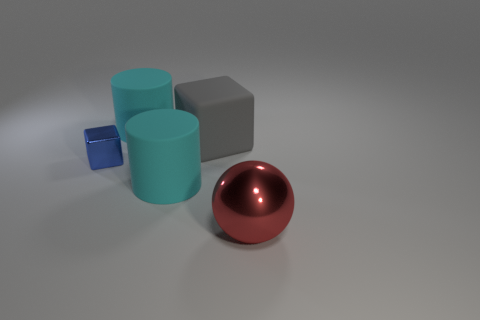How many other objects are the same color as the shiny ball?
Make the answer very short. 0. There is a shiny thing on the left side of the red shiny thing; does it have the same shape as the rubber object in front of the tiny shiny block?
Your answer should be compact. No. Is there a matte object that has the same size as the blue shiny cube?
Keep it short and to the point. No. There is a cyan cylinder behind the metal block; what is it made of?
Provide a short and direct response. Rubber. Do the cube that is on the left side of the gray matte block and the sphere have the same material?
Your answer should be compact. Yes. Is there a tiny gray matte cylinder?
Provide a succinct answer. No. There is another object that is made of the same material as the red thing; what is its color?
Keep it short and to the point. Blue. The thing that is to the left of the big rubber cylinder that is behind the shiny object that is behind the red sphere is what color?
Keep it short and to the point. Blue. There is a red sphere; is its size the same as the cube that is in front of the big cube?
Offer a terse response. No. How many things are metal objects behind the red ball or big gray rubber cubes that are right of the small thing?
Give a very brief answer. 2. 